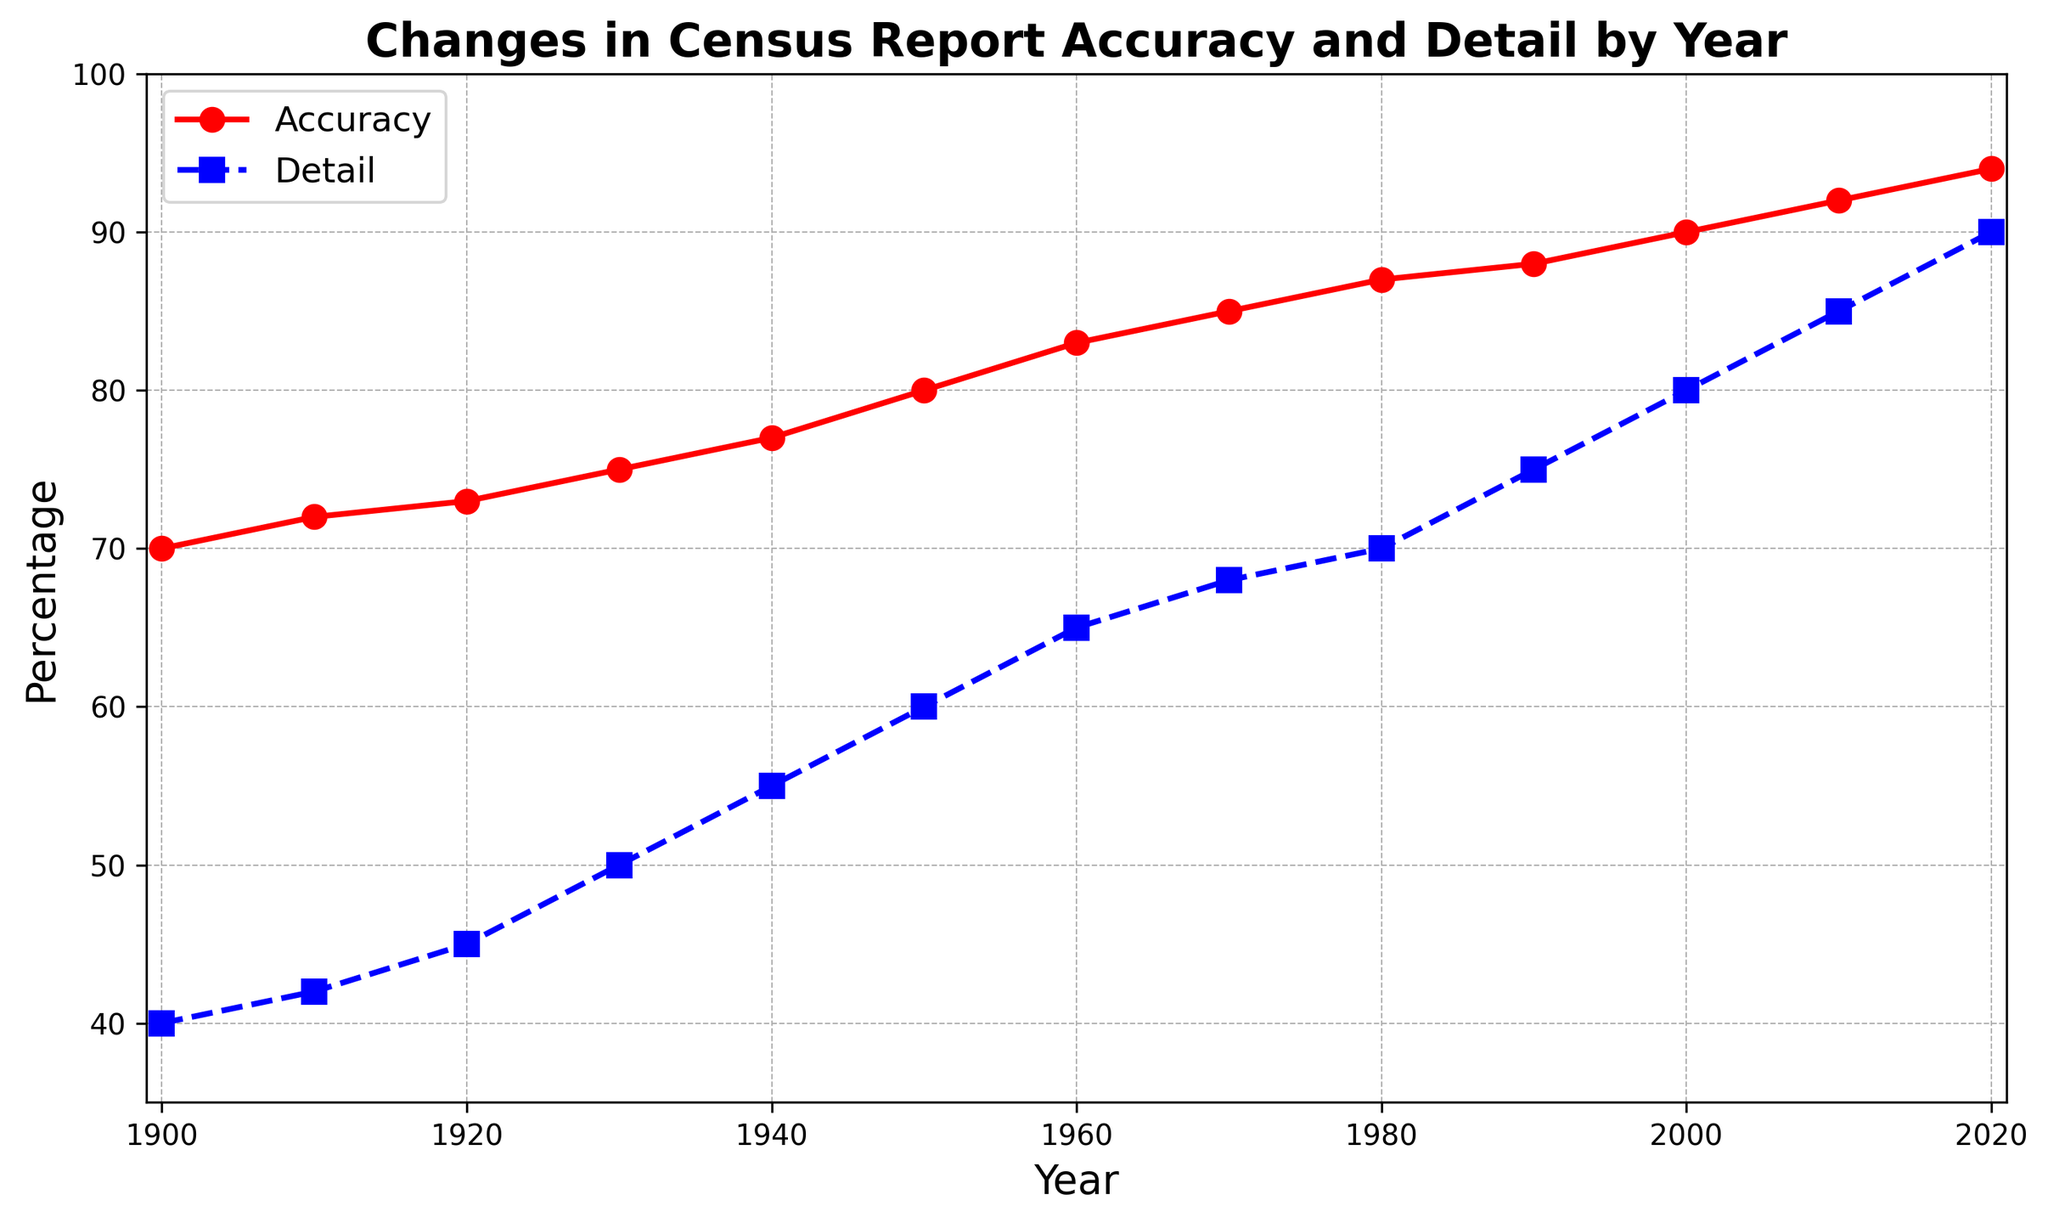What is the overall trend of accuracy from 1900 to 2020? The trend can be understood by observing the general direction of the red line representing accuracy. It starts at 70% in 1900 and steadily increases, reaching 94% by 2020. Thus, there is a consistent upward trend in accuracy over the years.
Answer: Increasing What year saw the detail percentage first exceed 70%? By inspecting the blue line representing detail, we see that it first surpasses the 70% mark in 1980, where the detail percentage reaches 75%.
Answer: 1980 From 1950 to 1960, how much did the accuracy increase? To find this, subtract the accuracy in 1950 (80%) from the accuracy in 1960 (83%): 83% - 80% = 3%.
Answer: 3% Which had a higher percentage in 1930, accuracy or detail? Comparing the values in 1930, accuracy is at 75% and detail is at 50%. Accuracy is higher.
Answer: Accuracy What year experienced the largest increase in accuracy over a decade? We need to compare the decade increases. 1900-1910: 72%-70%=2%, 1910-1920: 73%-72%=1%, 1920-1930: 75%-73%=2%, 1930-1940: 77%-75%=2%, 1940-1950: 80%-77%=3%, 1950-1960: 83%-80%=3%, 1960-1970: 85%-83%=2%, 1970-1980: 87%-85%=2%, 1980-1990: 88%-87%=1%, 1990-2000: 90%-88%=2%, 2000-2010: 92%-90%=2%, 2010-2020: 94%-92%=2%. Thus, 1940-1950 and 1950-1960 had the largest increase of 3%.
Answer: 1940-1960 Which metric, accuracy or detail, experienced a faster rate of increase over the entire period? Comparing the overall increase from 1900 to 2020 for both metrics: Accuracy increased from 70% to 94% (24%), and detail increased from 40% to 90% (50%). So, detail had a faster rate of increase.
Answer: Detail By how much did the detail percentage increase from 2000 to 2020? Subtract the detail percentage in 2000 (80%) from that in 2020 (90%): 90% - 80% = 10%.
Answer: 10% In which year did accuracy reach 85%? Inspecting the red line, accuracy reaches 85% in the year 1970.
Answer: 1970 Is there a year when both accuracy and detail are equal? By examining the points where the red and blue lines intersect, we see that accuracy and detail never share the same percentage value in any given year.
Answer: No Describe the changes in accuracy and detail between 1930 and 1940? Between these years, accuracy increased from 75% to 77% (2% increase), and detail rose from 50% to 55% (5% increase).
Answer: Accuracy increased by 2%, and detail increased by 5% 